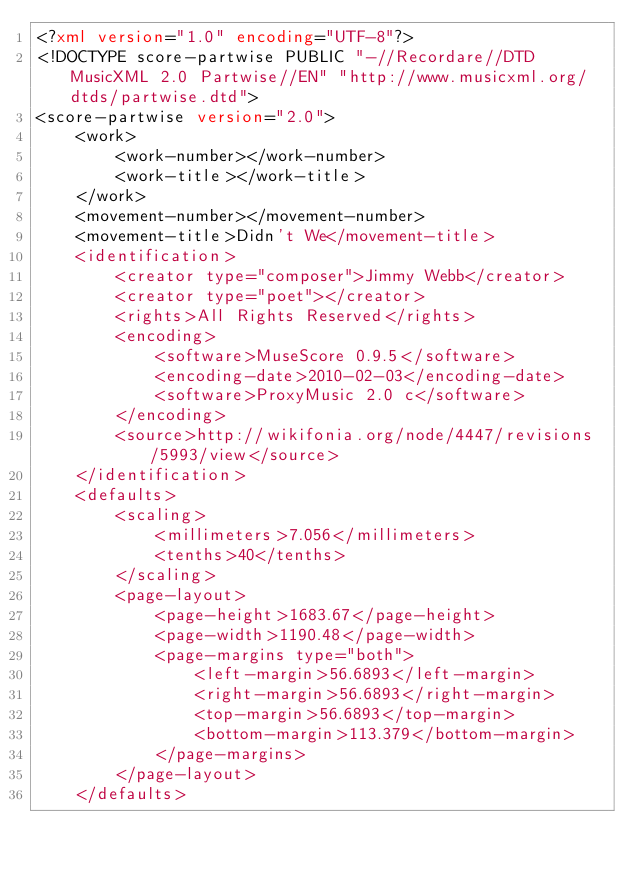Convert code to text. <code><loc_0><loc_0><loc_500><loc_500><_XML_><?xml version="1.0" encoding="UTF-8"?>
<!DOCTYPE score-partwise PUBLIC "-//Recordare//DTD MusicXML 2.0 Partwise//EN" "http://www.musicxml.org/dtds/partwise.dtd">
<score-partwise version="2.0">
    <work>
        <work-number></work-number>
        <work-title></work-title>
    </work>
    <movement-number></movement-number>
    <movement-title>Didn't We</movement-title>
    <identification>
        <creator type="composer">Jimmy Webb</creator>
        <creator type="poet"></creator>
        <rights>All Rights Reserved</rights>
        <encoding>
            <software>MuseScore 0.9.5</software>
            <encoding-date>2010-02-03</encoding-date>
            <software>ProxyMusic 2.0 c</software>
        </encoding>
        <source>http://wikifonia.org/node/4447/revisions/5993/view</source>
    </identification>
    <defaults>
        <scaling>
            <millimeters>7.056</millimeters>
            <tenths>40</tenths>
        </scaling>
        <page-layout>
            <page-height>1683.67</page-height>
            <page-width>1190.48</page-width>
            <page-margins type="both">
                <left-margin>56.6893</left-margin>
                <right-margin>56.6893</right-margin>
                <top-margin>56.6893</top-margin>
                <bottom-margin>113.379</bottom-margin>
            </page-margins>
        </page-layout>
    </defaults></code> 